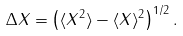<formula> <loc_0><loc_0><loc_500><loc_500>\Delta X = \left ( \langle X ^ { 2 } \rangle - \langle X \rangle ^ { 2 } \right ) ^ { 1 / 2 } .</formula> 